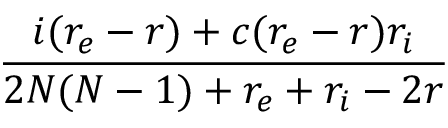<formula> <loc_0><loc_0><loc_500><loc_500>\frac { i ( r _ { e } - r ) + c ( r _ { e } - r ) r _ { i } } { 2 N ( N - 1 ) + r _ { e } + r _ { i } - 2 r }</formula> 